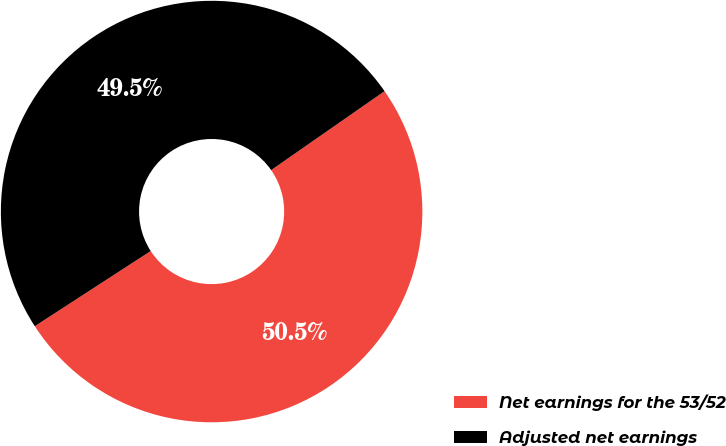<chart> <loc_0><loc_0><loc_500><loc_500><pie_chart><fcel>Net earnings for the 53/52<fcel>Adjusted net earnings<nl><fcel>50.52%<fcel>49.48%<nl></chart> 